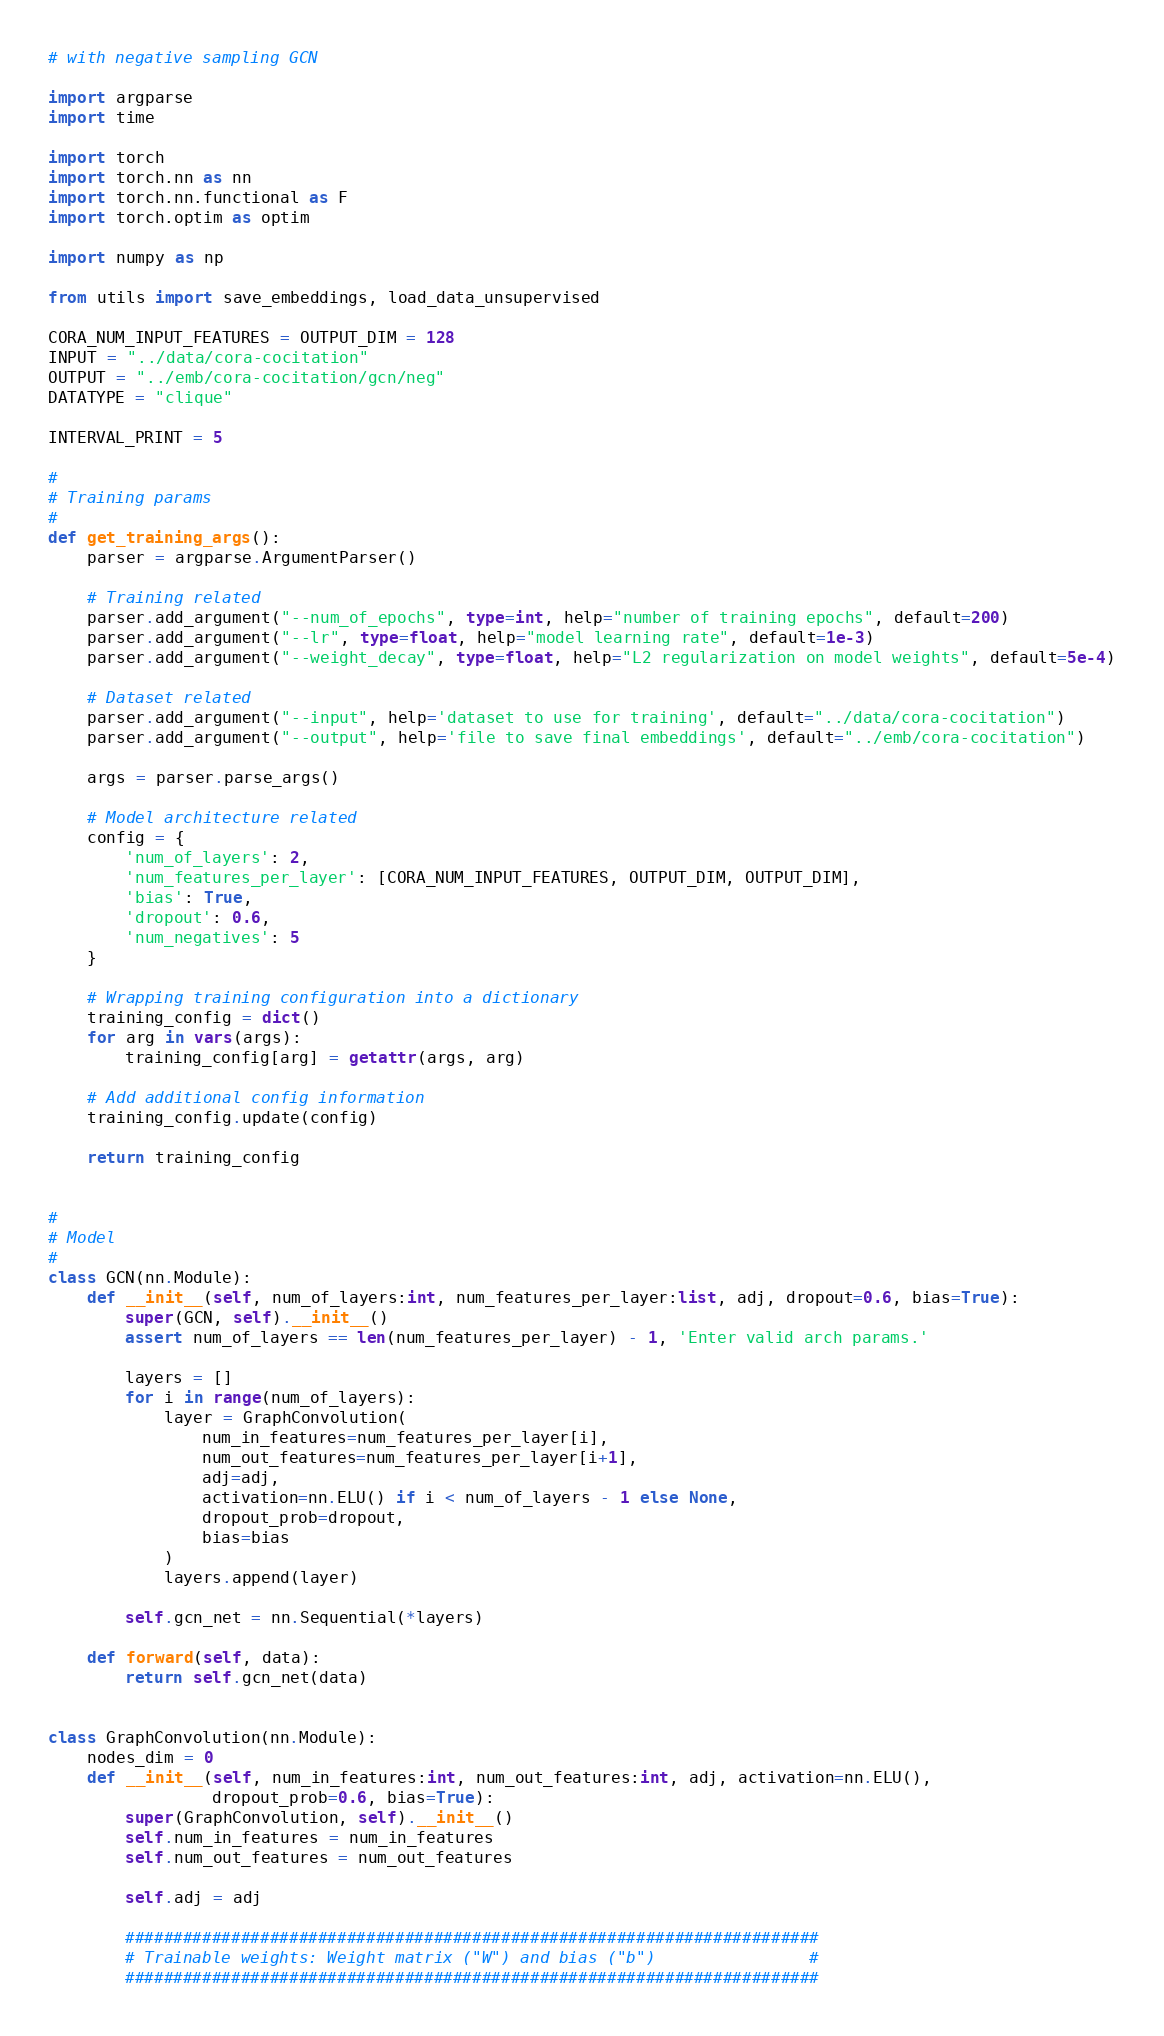Convert code to text. <code><loc_0><loc_0><loc_500><loc_500><_Python_># with negative sampling GCN

import argparse
import time

import torch
import torch.nn as nn
import torch.nn.functional as F
import torch.optim as optim

import numpy as np

from utils import save_embeddings, load_data_unsupervised

CORA_NUM_INPUT_FEATURES = OUTPUT_DIM = 128
INPUT = "../data/cora-cocitation"
OUTPUT = "../emb/cora-cocitation/gcn/neg"
DATATYPE = "clique"

INTERVAL_PRINT = 5

#
# Training params
#
def get_training_args():
    parser = argparse.ArgumentParser()

    # Training related
    parser.add_argument("--num_of_epochs", type=int, help="number of training epochs", default=200)
    parser.add_argument("--lr", type=float, help="model learning rate", default=1e-3)
    parser.add_argument("--weight_decay", type=float, help="L2 regularization on model weights", default=5e-4)

    # Dataset related
    parser.add_argument("--input", help='dataset to use for training', default="../data/cora-cocitation")
    parser.add_argument("--output", help='file to save final embeddings', default="../emb/cora-cocitation")

    args = parser.parse_args()

    # Model architecture related
    config = {
        'num_of_layers': 2,
        'num_features_per_layer': [CORA_NUM_INPUT_FEATURES, OUTPUT_DIM, OUTPUT_DIM],
        'bias': True,
        'dropout': 0.6,
        'num_negatives': 5
    }

    # Wrapping training configuration into a dictionary
    training_config = dict()
    for arg in vars(args):
        training_config[arg] = getattr(args, arg)

    # Add additional config information
    training_config.update(config)

    return training_config


#
# Model
#
class GCN(nn.Module):
    def __init__(self, num_of_layers:int, num_features_per_layer:list, adj, dropout=0.6, bias=True):
        super(GCN, self).__init__()
        assert num_of_layers == len(num_features_per_layer) - 1, 'Enter valid arch params.'

        layers = []
        for i in range(num_of_layers):
            layer = GraphConvolution(
                num_in_features=num_features_per_layer[i],
                num_out_features=num_features_per_layer[i+1],
                adj=adj,
                activation=nn.ELU() if i < num_of_layers - 1 else None,
                dropout_prob=dropout,
                bias=bias
            )
            layers.append(layer)

        self.gcn_net = nn.Sequential(*layers)

    def forward(self, data):
        return self.gcn_net(data)


class GraphConvolution(nn.Module):
    nodes_dim = 0
    def __init__(self, num_in_features:int, num_out_features:int, adj, activation=nn.ELU(),
                 dropout_prob=0.6, bias=True):
        super(GraphConvolution, self).__init__()
        self.num_in_features = num_in_features
        self.num_out_features = num_out_features

        self.adj = adj

        ########################################################################
        # Trainable weights: Weight matrix ("W") and bias ("b")                #
        ########################################################################</code> 